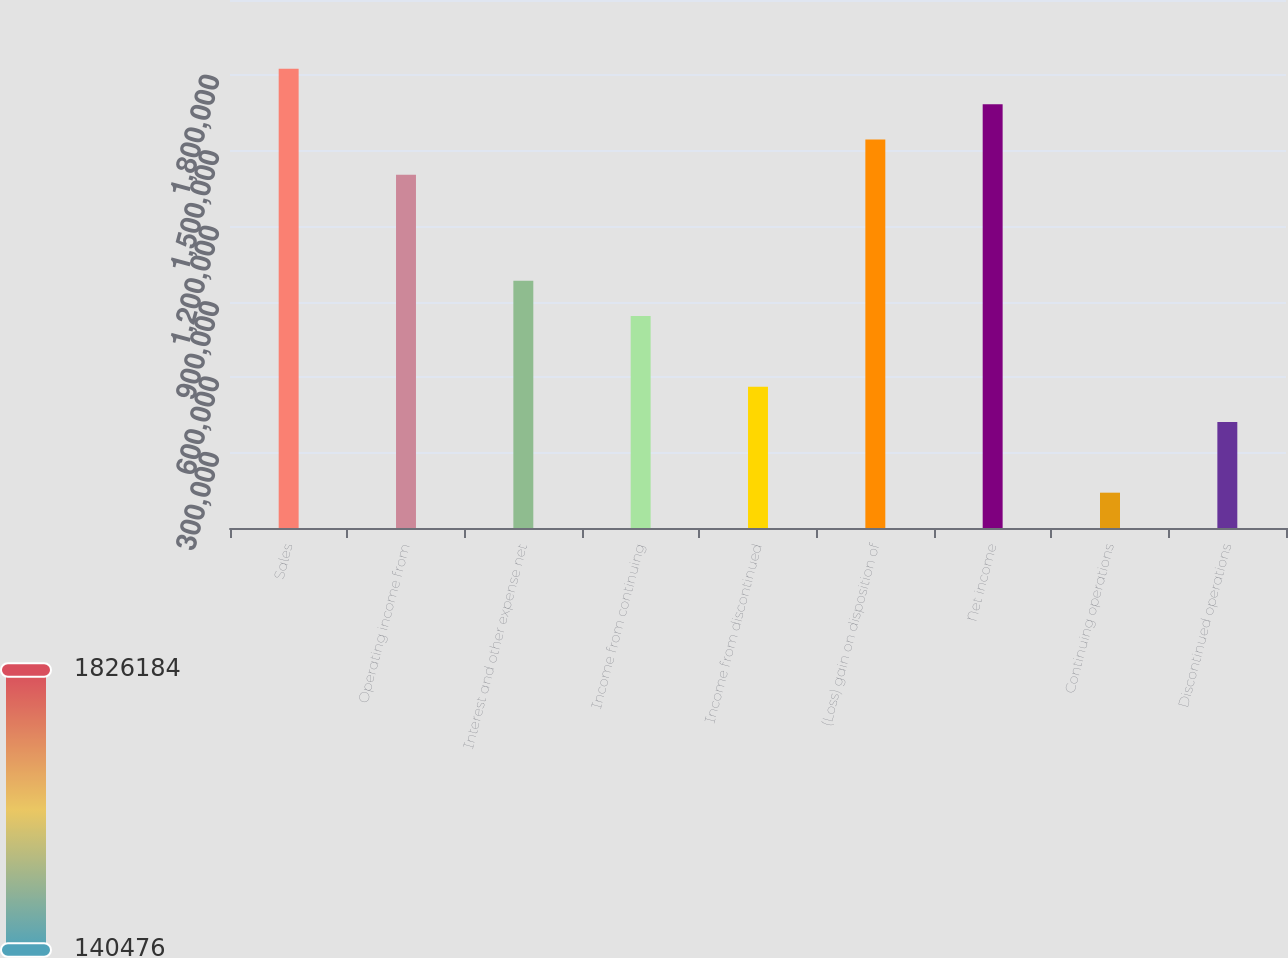Convert chart. <chart><loc_0><loc_0><loc_500><loc_500><bar_chart><fcel>Sales<fcel>Operating income from<fcel>Interest and other expense net<fcel>Income from continuing<fcel>Income from discontinued<fcel>(Loss) gain on disposition of<fcel>Net income<fcel>Continuing operations<fcel>Discontinued operations<nl><fcel>1.82618e+06<fcel>1.40476e+06<fcel>983330<fcel>842854<fcel>561903<fcel>1.54523e+06<fcel>1.68571e+06<fcel>140476<fcel>421427<nl></chart> 